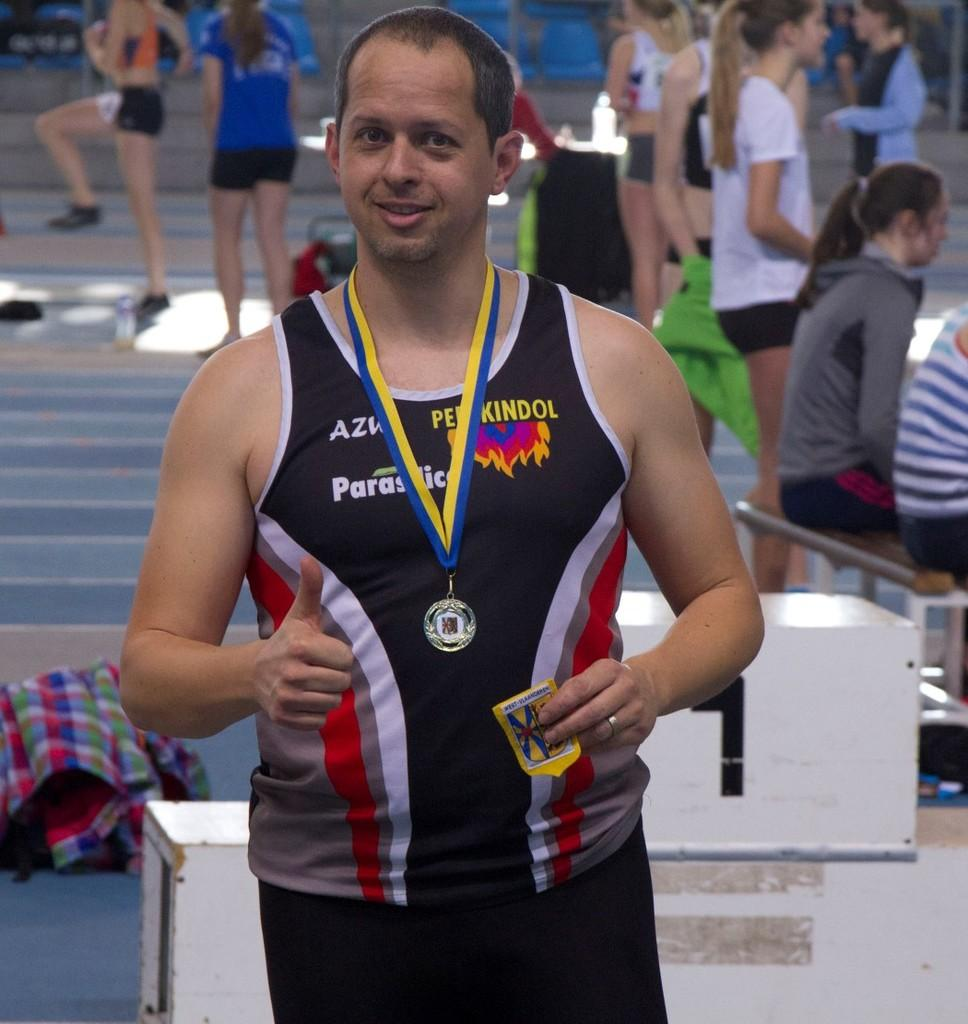What is the man in the image doing? The man is standing in the image. What is the man wearing? The man is wearing a black jersey. Does the man have any notable accessory or achievement? Yes, the man has a medal. What can be seen in the background of the image? There are people in the background of the image. What are the people in the background doing? The people in the background are practicing. What is the actor's opinion on the smashing of the vase in the image? There is no actor or vase present in the image, so it is not possible to determine their opinion on the smashing of a vase. 